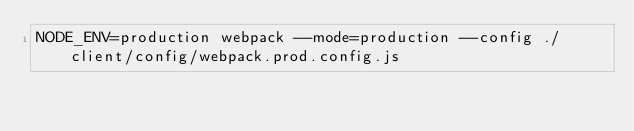<code> <loc_0><loc_0><loc_500><loc_500><_Bash_>NODE_ENV=production webpack --mode=production --config ./client/config/webpack.prod.config.js
</code> 